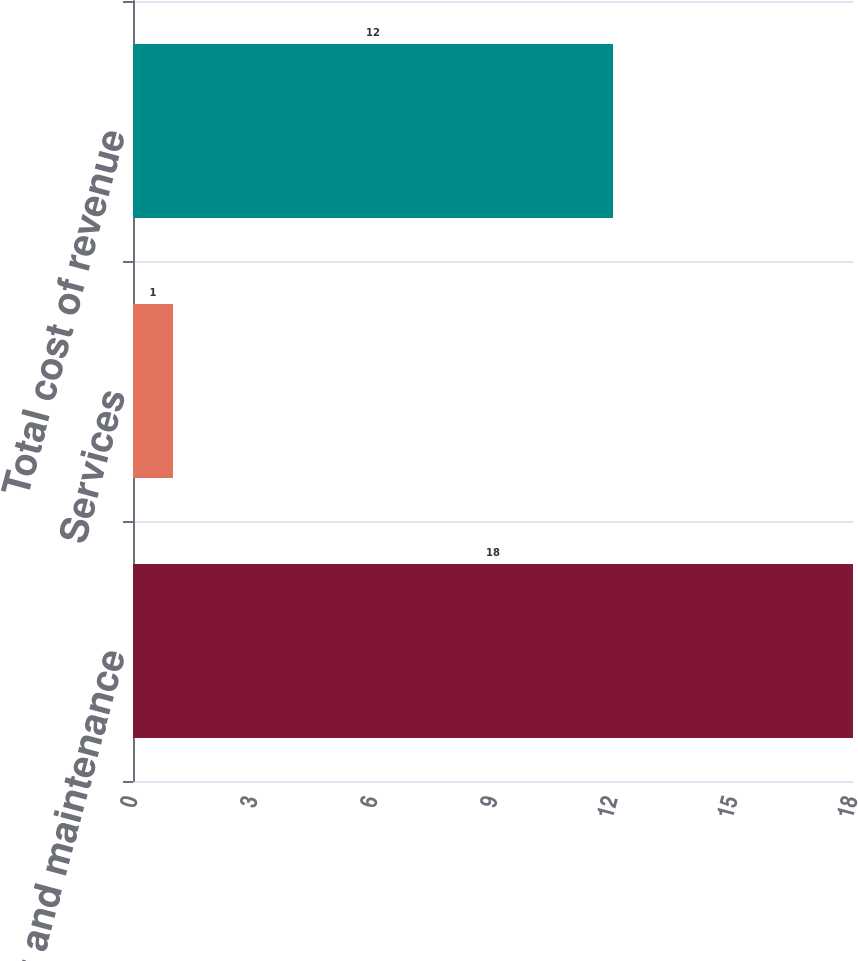Convert chart. <chart><loc_0><loc_0><loc_500><loc_500><bar_chart><fcel>Product and maintenance<fcel>Services<fcel>Total cost of revenue<nl><fcel>18<fcel>1<fcel>12<nl></chart> 